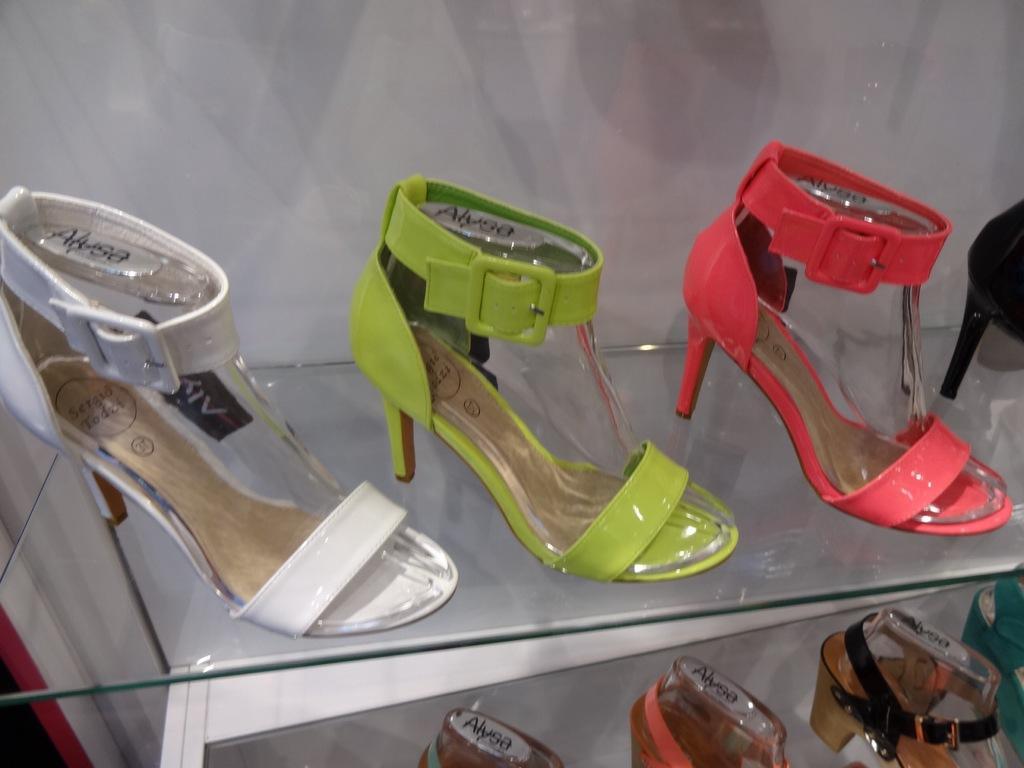Please provide a concise description of this image. In this image I see the footwear on the glass and I see they're off white, green, pink, black and brown in color and I see words written on it and I see the white wall. 